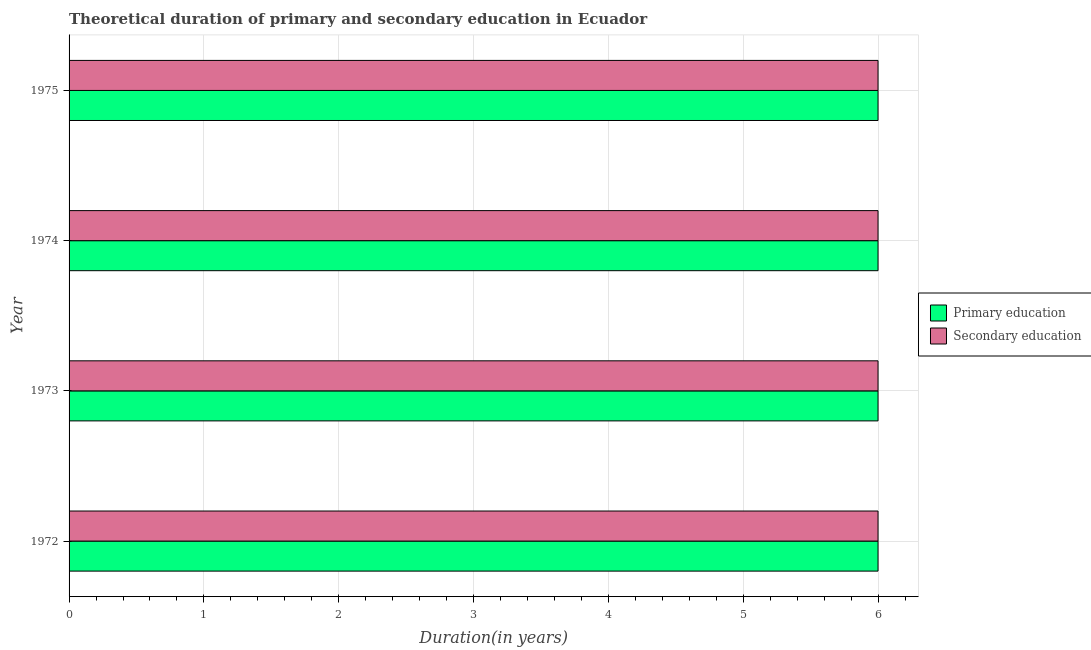How many different coloured bars are there?
Your answer should be very brief. 2. How many groups of bars are there?
Provide a succinct answer. 4. How many bars are there on the 2nd tick from the top?
Offer a very short reply. 2. In how many cases, is the number of bars for a given year not equal to the number of legend labels?
Provide a short and direct response. 0. Across all years, what is the maximum duration of secondary education?
Keep it short and to the point. 6. In which year was the duration of primary education maximum?
Give a very brief answer. 1972. In which year was the duration of secondary education minimum?
Offer a very short reply. 1972. What is the total duration of primary education in the graph?
Ensure brevity in your answer.  24. What is the difference between the duration of secondary education in 1973 and that in 1974?
Ensure brevity in your answer.  0. What is the average duration of primary education per year?
Offer a very short reply. 6. In the year 1973, what is the difference between the duration of primary education and duration of secondary education?
Provide a succinct answer. 0. What is the ratio of the duration of primary education in 1974 to that in 1975?
Your answer should be compact. 1. What is the difference between the highest and the second highest duration of secondary education?
Keep it short and to the point. 0. Is the sum of the duration of secondary education in 1972 and 1973 greater than the maximum duration of primary education across all years?
Provide a short and direct response. Yes. What does the 1st bar from the top in 1972 represents?
Give a very brief answer. Secondary education. What does the 2nd bar from the bottom in 1972 represents?
Provide a short and direct response. Secondary education. How many years are there in the graph?
Provide a succinct answer. 4. Are the values on the major ticks of X-axis written in scientific E-notation?
Keep it short and to the point. No. Does the graph contain grids?
Provide a succinct answer. Yes. Where does the legend appear in the graph?
Provide a succinct answer. Center right. How many legend labels are there?
Give a very brief answer. 2. How are the legend labels stacked?
Keep it short and to the point. Vertical. What is the title of the graph?
Ensure brevity in your answer.  Theoretical duration of primary and secondary education in Ecuador. Does "All education staff compensation" appear as one of the legend labels in the graph?
Give a very brief answer. No. What is the label or title of the X-axis?
Ensure brevity in your answer.  Duration(in years). What is the label or title of the Y-axis?
Provide a short and direct response. Year. What is the Duration(in years) of Secondary education in 1972?
Your response must be concise. 6. What is the Duration(in years) in Primary education in 1973?
Your answer should be compact. 6. What is the Duration(in years) of Secondary education in 1974?
Keep it short and to the point. 6. What is the Duration(in years) in Primary education in 1975?
Offer a terse response. 6. What is the Duration(in years) in Secondary education in 1975?
Your answer should be very brief. 6. Across all years, what is the maximum Duration(in years) in Primary education?
Give a very brief answer. 6. Across all years, what is the maximum Duration(in years) in Secondary education?
Keep it short and to the point. 6. Across all years, what is the minimum Duration(in years) in Secondary education?
Your response must be concise. 6. What is the difference between the Duration(in years) of Primary education in 1972 and that in 1973?
Provide a succinct answer. 0. What is the difference between the Duration(in years) of Secondary education in 1972 and that in 1973?
Your answer should be very brief. 0. What is the difference between the Duration(in years) in Secondary education in 1972 and that in 1974?
Keep it short and to the point. 0. What is the difference between the Duration(in years) of Primary education in 1972 and that in 1975?
Keep it short and to the point. 0. What is the difference between the Duration(in years) in Secondary education in 1972 and that in 1975?
Your answer should be compact. 0. What is the difference between the Duration(in years) of Primary education in 1973 and that in 1974?
Your answer should be very brief. 0. What is the difference between the Duration(in years) of Primary education in 1973 and that in 1975?
Ensure brevity in your answer.  0. What is the difference between the Duration(in years) of Primary education in 1974 and that in 1975?
Your response must be concise. 0. What is the difference between the Duration(in years) of Secondary education in 1974 and that in 1975?
Your response must be concise. 0. What is the difference between the Duration(in years) in Primary education in 1972 and the Duration(in years) in Secondary education in 1973?
Your answer should be compact. 0. What is the difference between the Duration(in years) in Primary education in 1973 and the Duration(in years) in Secondary education in 1975?
Your answer should be very brief. 0. What is the difference between the Duration(in years) in Primary education in 1974 and the Duration(in years) in Secondary education in 1975?
Ensure brevity in your answer.  0. What is the average Duration(in years) in Primary education per year?
Make the answer very short. 6. In the year 1972, what is the difference between the Duration(in years) of Primary education and Duration(in years) of Secondary education?
Your answer should be very brief. 0. In the year 1975, what is the difference between the Duration(in years) in Primary education and Duration(in years) in Secondary education?
Ensure brevity in your answer.  0. What is the ratio of the Duration(in years) of Primary education in 1972 to that in 1974?
Keep it short and to the point. 1. What is the ratio of the Duration(in years) of Secondary education in 1972 to that in 1974?
Your response must be concise. 1. What is the ratio of the Duration(in years) of Primary education in 1972 to that in 1975?
Keep it short and to the point. 1. What is the ratio of the Duration(in years) of Secondary education in 1972 to that in 1975?
Your response must be concise. 1. What is the ratio of the Duration(in years) in Primary education in 1973 to that in 1974?
Provide a succinct answer. 1. What is the ratio of the Duration(in years) of Primary education in 1973 to that in 1975?
Make the answer very short. 1. What is the ratio of the Duration(in years) of Secondary education in 1973 to that in 1975?
Provide a succinct answer. 1. What is the ratio of the Duration(in years) in Primary education in 1974 to that in 1975?
Keep it short and to the point. 1. What is the difference between the highest and the second highest Duration(in years) in Secondary education?
Make the answer very short. 0. What is the difference between the highest and the lowest Duration(in years) in Secondary education?
Give a very brief answer. 0. 